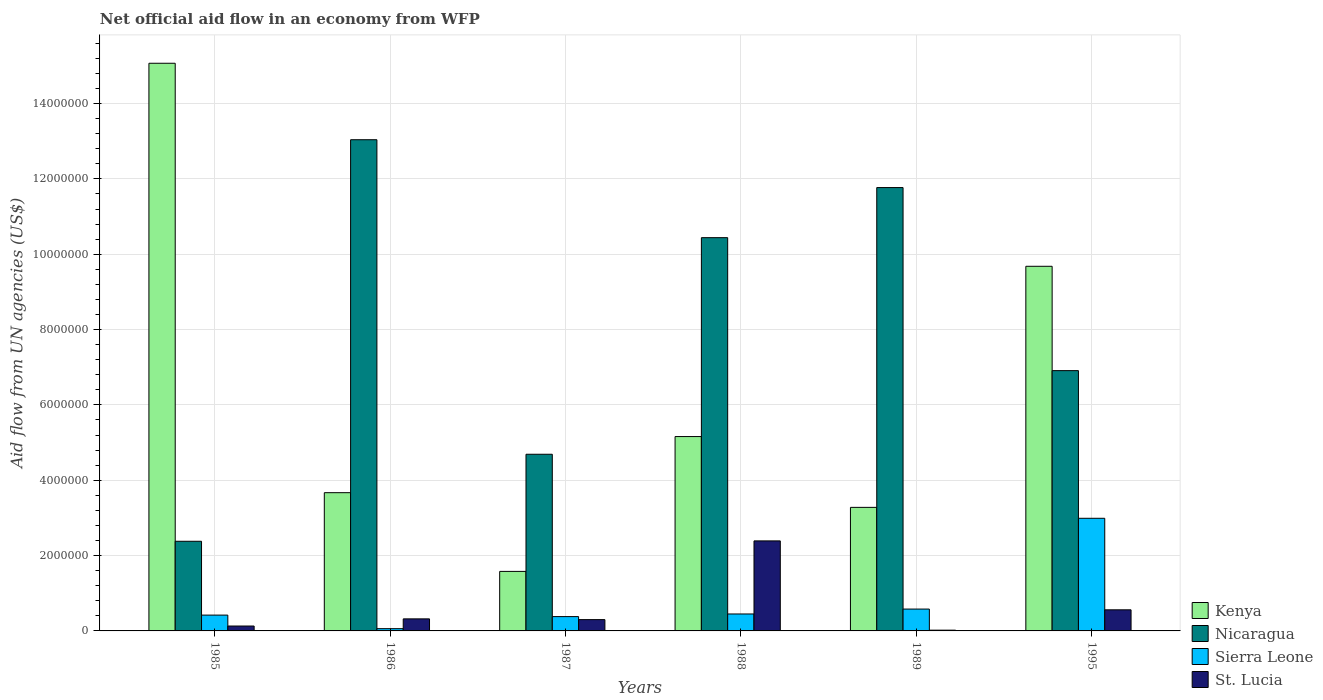How many bars are there on the 3rd tick from the left?
Your answer should be compact. 4. How many bars are there on the 6th tick from the right?
Offer a very short reply. 4. What is the label of the 3rd group of bars from the left?
Give a very brief answer. 1987. Across all years, what is the maximum net official aid flow in Nicaragua?
Offer a terse response. 1.30e+07. Across all years, what is the minimum net official aid flow in Nicaragua?
Provide a short and direct response. 2.38e+06. In which year was the net official aid flow in Nicaragua minimum?
Give a very brief answer. 1985. What is the total net official aid flow in St. Lucia in the graph?
Your answer should be compact. 3.72e+06. What is the difference between the net official aid flow in Nicaragua in 1986 and that in 1988?
Offer a terse response. 2.60e+06. What is the difference between the net official aid flow in St. Lucia in 1988 and the net official aid flow in Sierra Leone in 1987?
Your answer should be compact. 2.01e+06. What is the average net official aid flow in Sierra Leone per year?
Provide a short and direct response. 8.13e+05. In the year 1985, what is the difference between the net official aid flow in St. Lucia and net official aid flow in Kenya?
Your response must be concise. -1.49e+07. What is the ratio of the net official aid flow in Nicaragua in 1985 to that in 1986?
Your answer should be very brief. 0.18. What is the difference between the highest and the second highest net official aid flow in Sierra Leone?
Ensure brevity in your answer.  2.41e+06. What is the difference between the highest and the lowest net official aid flow in Kenya?
Offer a terse response. 1.35e+07. Is the sum of the net official aid flow in Sierra Leone in 1985 and 1995 greater than the maximum net official aid flow in Nicaragua across all years?
Ensure brevity in your answer.  No. What does the 1st bar from the left in 1985 represents?
Offer a terse response. Kenya. What does the 1st bar from the right in 1986 represents?
Your response must be concise. St. Lucia. Is it the case that in every year, the sum of the net official aid flow in Kenya and net official aid flow in Nicaragua is greater than the net official aid flow in Sierra Leone?
Offer a terse response. Yes. How many years are there in the graph?
Keep it short and to the point. 6. Are the values on the major ticks of Y-axis written in scientific E-notation?
Offer a terse response. No. Does the graph contain grids?
Your answer should be compact. Yes. Where does the legend appear in the graph?
Offer a terse response. Bottom right. How are the legend labels stacked?
Offer a very short reply. Vertical. What is the title of the graph?
Keep it short and to the point. Net official aid flow in an economy from WFP. Does "Marshall Islands" appear as one of the legend labels in the graph?
Your response must be concise. No. What is the label or title of the Y-axis?
Provide a succinct answer. Aid flow from UN agencies (US$). What is the Aid flow from UN agencies (US$) in Kenya in 1985?
Offer a very short reply. 1.51e+07. What is the Aid flow from UN agencies (US$) of Nicaragua in 1985?
Provide a short and direct response. 2.38e+06. What is the Aid flow from UN agencies (US$) in Sierra Leone in 1985?
Your answer should be very brief. 4.20e+05. What is the Aid flow from UN agencies (US$) in St. Lucia in 1985?
Offer a terse response. 1.30e+05. What is the Aid flow from UN agencies (US$) of Kenya in 1986?
Your answer should be very brief. 3.67e+06. What is the Aid flow from UN agencies (US$) in Nicaragua in 1986?
Provide a short and direct response. 1.30e+07. What is the Aid flow from UN agencies (US$) in St. Lucia in 1986?
Ensure brevity in your answer.  3.20e+05. What is the Aid flow from UN agencies (US$) of Kenya in 1987?
Give a very brief answer. 1.58e+06. What is the Aid flow from UN agencies (US$) in Nicaragua in 1987?
Keep it short and to the point. 4.69e+06. What is the Aid flow from UN agencies (US$) in St. Lucia in 1987?
Provide a succinct answer. 3.00e+05. What is the Aid flow from UN agencies (US$) in Kenya in 1988?
Your answer should be compact. 5.16e+06. What is the Aid flow from UN agencies (US$) of Nicaragua in 1988?
Ensure brevity in your answer.  1.04e+07. What is the Aid flow from UN agencies (US$) of Sierra Leone in 1988?
Provide a short and direct response. 4.50e+05. What is the Aid flow from UN agencies (US$) in St. Lucia in 1988?
Offer a terse response. 2.39e+06. What is the Aid flow from UN agencies (US$) in Kenya in 1989?
Your answer should be compact. 3.28e+06. What is the Aid flow from UN agencies (US$) of Nicaragua in 1989?
Provide a short and direct response. 1.18e+07. What is the Aid flow from UN agencies (US$) in Sierra Leone in 1989?
Provide a succinct answer. 5.80e+05. What is the Aid flow from UN agencies (US$) in St. Lucia in 1989?
Give a very brief answer. 2.00e+04. What is the Aid flow from UN agencies (US$) in Kenya in 1995?
Make the answer very short. 9.68e+06. What is the Aid flow from UN agencies (US$) in Nicaragua in 1995?
Keep it short and to the point. 6.91e+06. What is the Aid flow from UN agencies (US$) in Sierra Leone in 1995?
Make the answer very short. 2.99e+06. What is the Aid flow from UN agencies (US$) of St. Lucia in 1995?
Keep it short and to the point. 5.60e+05. Across all years, what is the maximum Aid flow from UN agencies (US$) in Kenya?
Your answer should be very brief. 1.51e+07. Across all years, what is the maximum Aid flow from UN agencies (US$) in Nicaragua?
Your answer should be very brief. 1.30e+07. Across all years, what is the maximum Aid flow from UN agencies (US$) in Sierra Leone?
Keep it short and to the point. 2.99e+06. Across all years, what is the maximum Aid flow from UN agencies (US$) in St. Lucia?
Your answer should be very brief. 2.39e+06. Across all years, what is the minimum Aid flow from UN agencies (US$) in Kenya?
Give a very brief answer. 1.58e+06. Across all years, what is the minimum Aid flow from UN agencies (US$) of Nicaragua?
Offer a very short reply. 2.38e+06. Across all years, what is the minimum Aid flow from UN agencies (US$) in Sierra Leone?
Your response must be concise. 6.00e+04. Across all years, what is the minimum Aid flow from UN agencies (US$) of St. Lucia?
Offer a terse response. 2.00e+04. What is the total Aid flow from UN agencies (US$) in Kenya in the graph?
Your answer should be very brief. 3.84e+07. What is the total Aid flow from UN agencies (US$) in Nicaragua in the graph?
Your answer should be very brief. 4.92e+07. What is the total Aid flow from UN agencies (US$) in Sierra Leone in the graph?
Your answer should be compact. 4.88e+06. What is the total Aid flow from UN agencies (US$) of St. Lucia in the graph?
Your answer should be very brief. 3.72e+06. What is the difference between the Aid flow from UN agencies (US$) of Kenya in 1985 and that in 1986?
Ensure brevity in your answer.  1.14e+07. What is the difference between the Aid flow from UN agencies (US$) in Nicaragua in 1985 and that in 1986?
Keep it short and to the point. -1.07e+07. What is the difference between the Aid flow from UN agencies (US$) of Kenya in 1985 and that in 1987?
Provide a short and direct response. 1.35e+07. What is the difference between the Aid flow from UN agencies (US$) in Nicaragua in 1985 and that in 1987?
Your response must be concise. -2.31e+06. What is the difference between the Aid flow from UN agencies (US$) of St. Lucia in 1985 and that in 1987?
Keep it short and to the point. -1.70e+05. What is the difference between the Aid flow from UN agencies (US$) in Kenya in 1985 and that in 1988?
Offer a very short reply. 9.91e+06. What is the difference between the Aid flow from UN agencies (US$) of Nicaragua in 1985 and that in 1988?
Offer a very short reply. -8.06e+06. What is the difference between the Aid flow from UN agencies (US$) in St. Lucia in 1985 and that in 1988?
Offer a terse response. -2.26e+06. What is the difference between the Aid flow from UN agencies (US$) of Kenya in 1985 and that in 1989?
Give a very brief answer. 1.18e+07. What is the difference between the Aid flow from UN agencies (US$) of Nicaragua in 1985 and that in 1989?
Your answer should be very brief. -9.39e+06. What is the difference between the Aid flow from UN agencies (US$) of Sierra Leone in 1985 and that in 1989?
Provide a short and direct response. -1.60e+05. What is the difference between the Aid flow from UN agencies (US$) of Kenya in 1985 and that in 1995?
Your answer should be compact. 5.39e+06. What is the difference between the Aid flow from UN agencies (US$) in Nicaragua in 1985 and that in 1995?
Give a very brief answer. -4.53e+06. What is the difference between the Aid flow from UN agencies (US$) of Sierra Leone in 1985 and that in 1995?
Your answer should be very brief. -2.57e+06. What is the difference between the Aid flow from UN agencies (US$) in St. Lucia in 1985 and that in 1995?
Make the answer very short. -4.30e+05. What is the difference between the Aid flow from UN agencies (US$) of Kenya in 1986 and that in 1987?
Offer a very short reply. 2.09e+06. What is the difference between the Aid flow from UN agencies (US$) of Nicaragua in 1986 and that in 1987?
Your answer should be very brief. 8.35e+06. What is the difference between the Aid flow from UN agencies (US$) of Sierra Leone in 1986 and that in 1987?
Keep it short and to the point. -3.20e+05. What is the difference between the Aid flow from UN agencies (US$) in Kenya in 1986 and that in 1988?
Your response must be concise. -1.49e+06. What is the difference between the Aid flow from UN agencies (US$) of Nicaragua in 1986 and that in 1988?
Your answer should be compact. 2.60e+06. What is the difference between the Aid flow from UN agencies (US$) of Sierra Leone in 1986 and that in 1988?
Ensure brevity in your answer.  -3.90e+05. What is the difference between the Aid flow from UN agencies (US$) of St. Lucia in 1986 and that in 1988?
Make the answer very short. -2.07e+06. What is the difference between the Aid flow from UN agencies (US$) in Nicaragua in 1986 and that in 1989?
Keep it short and to the point. 1.27e+06. What is the difference between the Aid flow from UN agencies (US$) of Sierra Leone in 1986 and that in 1989?
Make the answer very short. -5.20e+05. What is the difference between the Aid flow from UN agencies (US$) in St. Lucia in 1986 and that in 1989?
Ensure brevity in your answer.  3.00e+05. What is the difference between the Aid flow from UN agencies (US$) in Kenya in 1986 and that in 1995?
Provide a short and direct response. -6.01e+06. What is the difference between the Aid flow from UN agencies (US$) of Nicaragua in 1986 and that in 1995?
Offer a very short reply. 6.13e+06. What is the difference between the Aid flow from UN agencies (US$) of Sierra Leone in 1986 and that in 1995?
Ensure brevity in your answer.  -2.93e+06. What is the difference between the Aid flow from UN agencies (US$) of Kenya in 1987 and that in 1988?
Make the answer very short. -3.58e+06. What is the difference between the Aid flow from UN agencies (US$) of Nicaragua in 1987 and that in 1988?
Your response must be concise. -5.75e+06. What is the difference between the Aid flow from UN agencies (US$) in Sierra Leone in 1987 and that in 1988?
Offer a terse response. -7.00e+04. What is the difference between the Aid flow from UN agencies (US$) in St. Lucia in 1987 and that in 1988?
Ensure brevity in your answer.  -2.09e+06. What is the difference between the Aid flow from UN agencies (US$) in Kenya in 1987 and that in 1989?
Your response must be concise. -1.70e+06. What is the difference between the Aid flow from UN agencies (US$) of Nicaragua in 1987 and that in 1989?
Make the answer very short. -7.08e+06. What is the difference between the Aid flow from UN agencies (US$) of Sierra Leone in 1987 and that in 1989?
Offer a very short reply. -2.00e+05. What is the difference between the Aid flow from UN agencies (US$) of Kenya in 1987 and that in 1995?
Make the answer very short. -8.10e+06. What is the difference between the Aid flow from UN agencies (US$) of Nicaragua in 1987 and that in 1995?
Keep it short and to the point. -2.22e+06. What is the difference between the Aid flow from UN agencies (US$) of Sierra Leone in 1987 and that in 1995?
Keep it short and to the point. -2.61e+06. What is the difference between the Aid flow from UN agencies (US$) in Kenya in 1988 and that in 1989?
Your response must be concise. 1.88e+06. What is the difference between the Aid flow from UN agencies (US$) of Nicaragua in 1988 and that in 1989?
Give a very brief answer. -1.33e+06. What is the difference between the Aid flow from UN agencies (US$) in Sierra Leone in 1988 and that in 1989?
Provide a succinct answer. -1.30e+05. What is the difference between the Aid flow from UN agencies (US$) in St. Lucia in 1988 and that in 1989?
Offer a terse response. 2.37e+06. What is the difference between the Aid flow from UN agencies (US$) in Kenya in 1988 and that in 1995?
Your answer should be very brief. -4.52e+06. What is the difference between the Aid flow from UN agencies (US$) of Nicaragua in 1988 and that in 1995?
Keep it short and to the point. 3.53e+06. What is the difference between the Aid flow from UN agencies (US$) in Sierra Leone in 1988 and that in 1995?
Provide a short and direct response. -2.54e+06. What is the difference between the Aid flow from UN agencies (US$) in St. Lucia in 1988 and that in 1995?
Provide a short and direct response. 1.83e+06. What is the difference between the Aid flow from UN agencies (US$) in Kenya in 1989 and that in 1995?
Your response must be concise. -6.40e+06. What is the difference between the Aid flow from UN agencies (US$) in Nicaragua in 1989 and that in 1995?
Provide a short and direct response. 4.86e+06. What is the difference between the Aid flow from UN agencies (US$) in Sierra Leone in 1989 and that in 1995?
Provide a short and direct response. -2.41e+06. What is the difference between the Aid flow from UN agencies (US$) in St. Lucia in 1989 and that in 1995?
Make the answer very short. -5.40e+05. What is the difference between the Aid flow from UN agencies (US$) of Kenya in 1985 and the Aid flow from UN agencies (US$) of Nicaragua in 1986?
Provide a succinct answer. 2.03e+06. What is the difference between the Aid flow from UN agencies (US$) of Kenya in 1985 and the Aid flow from UN agencies (US$) of Sierra Leone in 1986?
Make the answer very short. 1.50e+07. What is the difference between the Aid flow from UN agencies (US$) in Kenya in 1985 and the Aid flow from UN agencies (US$) in St. Lucia in 1986?
Offer a very short reply. 1.48e+07. What is the difference between the Aid flow from UN agencies (US$) in Nicaragua in 1985 and the Aid flow from UN agencies (US$) in Sierra Leone in 1986?
Ensure brevity in your answer.  2.32e+06. What is the difference between the Aid flow from UN agencies (US$) in Nicaragua in 1985 and the Aid flow from UN agencies (US$) in St. Lucia in 1986?
Offer a very short reply. 2.06e+06. What is the difference between the Aid flow from UN agencies (US$) of Sierra Leone in 1985 and the Aid flow from UN agencies (US$) of St. Lucia in 1986?
Offer a very short reply. 1.00e+05. What is the difference between the Aid flow from UN agencies (US$) in Kenya in 1985 and the Aid flow from UN agencies (US$) in Nicaragua in 1987?
Provide a succinct answer. 1.04e+07. What is the difference between the Aid flow from UN agencies (US$) of Kenya in 1985 and the Aid flow from UN agencies (US$) of Sierra Leone in 1987?
Make the answer very short. 1.47e+07. What is the difference between the Aid flow from UN agencies (US$) in Kenya in 1985 and the Aid flow from UN agencies (US$) in St. Lucia in 1987?
Your response must be concise. 1.48e+07. What is the difference between the Aid flow from UN agencies (US$) in Nicaragua in 1985 and the Aid flow from UN agencies (US$) in St. Lucia in 1987?
Provide a short and direct response. 2.08e+06. What is the difference between the Aid flow from UN agencies (US$) of Sierra Leone in 1985 and the Aid flow from UN agencies (US$) of St. Lucia in 1987?
Your answer should be very brief. 1.20e+05. What is the difference between the Aid flow from UN agencies (US$) of Kenya in 1985 and the Aid flow from UN agencies (US$) of Nicaragua in 1988?
Keep it short and to the point. 4.63e+06. What is the difference between the Aid flow from UN agencies (US$) of Kenya in 1985 and the Aid flow from UN agencies (US$) of Sierra Leone in 1988?
Offer a terse response. 1.46e+07. What is the difference between the Aid flow from UN agencies (US$) of Kenya in 1985 and the Aid flow from UN agencies (US$) of St. Lucia in 1988?
Make the answer very short. 1.27e+07. What is the difference between the Aid flow from UN agencies (US$) of Nicaragua in 1985 and the Aid flow from UN agencies (US$) of Sierra Leone in 1988?
Your response must be concise. 1.93e+06. What is the difference between the Aid flow from UN agencies (US$) of Sierra Leone in 1985 and the Aid flow from UN agencies (US$) of St. Lucia in 1988?
Keep it short and to the point. -1.97e+06. What is the difference between the Aid flow from UN agencies (US$) in Kenya in 1985 and the Aid flow from UN agencies (US$) in Nicaragua in 1989?
Your response must be concise. 3.30e+06. What is the difference between the Aid flow from UN agencies (US$) of Kenya in 1985 and the Aid flow from UN agencies (US$) of Sierra Leone in 1989?
Offer a terse response. 1.45e+07. What is the difference between the Aid flow from UN agencies (US$) in Kenya in 1985 and the Aid flow from UN agencies (US$) in St. Lucia in 1989?
Your answer should be very brief. 1.50e+07. What is the difference between the Aid flow from UN agencies (US$) in Nicaragua in 1985 and the Aid flow from UN agencies (US$) in Sierra Leone in 1989?
Give a very brief answer. 1.80e+06. What is the difference between the Aid flow from UN agencies (US$) in Nicaragua in 1985 and the Aid flow from UN agencies (US$) in St. Lucia in 1989?
Offer a terse response. 2.36e+06. What is the difference between the Aid flow from UN agencies (US$) in Sierra Leone in 1985 and the Aid flow from UN agencies (US$) in St. Lucia in 1989?
Provide a succinct answer. 4.00e+05. What is the difference between the Aid flow from UN agencies (US$) in Kenya in 1985 and the Aid flow from UN agencies (US$) in Nicaragua in 1995?
Make the answer very short. 8.16e+06. What is the difference between the Aid flow from UN agencies (US$) of Kenya in 1985 and the Aid flow from UN agencies (US$) of Sierra Leone in 1995?
Ensure brevity in your answer.  1.21e+07. What is the difference between the Aid flow from UN agencies (US$) of Kenya in 1985 and the Aid flow from UN agencies (US$) of St. Lucia in 1995?
Your answer should be compact. 1.45e+07. What is the difference between the Aid flow from UN agencies (US$) in Nicaragua in 1985 and the Aid flow from UN agencies (US$) in Sierra Leone in 1995?
Make the answer very short. -6.10e+05. What is the difference between the Aid flow from UN agencies (US$) of Nicaragua in 1985 and the Aid flow from UN agencies (US$) of St. Lucia in 1995?
Ensure brevity in your answer.  1.82e+06. What is the difference between the Aid flow from UN agencies (US$) of Sierra Leone in 1985 and the Aid flow from UN agencies (US$) of St. Lucia in 1995?
Give a very brief answer. -1.40e+05. What is the difference between the Aid flow from UN agencies (US$) of Kenya in 1986 and the Aid flow from UN agencies (US$) of Nicaragua in 1987?
Offer a terse response. -1.02e+06. What is the difference between the Aid flow from UN agencies (US$) in Kenya in 1986 and the Aid flow from UN agencies (US$) in Sierra Leone in 1987?
Make the answer very short. 3.29e+06. What is the difference between the Aid flow from UN agencies (US$) in Kenya in 1986 and the Aid flow from UN agencies (US$) in St. Lucia in 1987?
Provide a succinct answer. 3.37e+06. What is the difference between the Aid flow from UN agencies (US$) of Nicaragua in 1986 and the Aid flow from UN agencies (US$) of Sierra Leone in 1987?
Offer a very short reply. 1.27e+07. What is the difference between the Aid flow from UN agencies (US$) of Nicaragua in 1986 and the Aid flow from UN agencies (US$) of St. Lucia in 1987?
Offer a terse response. 1.27e+07. What is the difference between the Aid flow from UN agencies (US$) of Kenya in 1986 and the Aid flow from UN agencies (US$) of Nicaragua in 1988?
Offer a very short reply. -6.77e+06. What is the difference between the Aid flow from UN agencies (US$) of Kenya in 1986 and the Aid flow from UN agencies (US$) of Sierra Leone in 1988?
Give a very brief answer. 3.22e+06. What is the difference between the Aid flow from UN agencies (US$) of Kenya in 1986 and the Aid flow from UN agencies (US$) of St. Lucia in 1988?
Your answer should be very brief. 1.28e+06. What is the difference between the Aid flow from UN agencies (US$) in Nicaragua in 1986 and the Aid flow from UN agencies (US$) in Sierra Leone in 1988?
Keep it short and to the point. 1.26e+07. What is the difference between the Aid flow from UN agencies (US$) in Nicaragua in 1986 and the Aid flow from UN agencies (US$) in St. Lucia in 1988?
Your answer should be compact. 1.06e+07. What is the difference between the Aid flow from UN agencies (US$) of Sierra Leone in 1986 and the Aid flow from UN agencies (US$) of St. Lucia in 1988?
Provide a short and direct response. -2.33e+06. What is the difference between the Aid flow from UN agencies (US$) of Kenya in 1986 and the Aid flow from UN agencies (US$) of Nicaragua in 1989?
Your answer should be very brief. -8.10e+06. What is the difference between the Aid flow from UN agencies (US$) in Kenya in 1986 and the Aid flow from UN agencies (US$) in Sierra Leone in 1989?
Your answer should be compact. 3.09e+06. What is the difference between the Aid flow from UN agencies (US$) in Kenya in 1986 and the Aid flow from UN agencies (US$) in St. Lucia in 1989?
Offer a very short reply. 3.65e+06. What is the difference between the Aid flow from UN agencies (US$) of Nicaragua in 1986 and the Aid flow from UN agencies (US$) of Sierra Leone in 1989?
Give a very brief answer. 1.25e+07. What is the difference between the Aid flow from UN agencies (US$) of Nicaragua in 1986 and the Aid flow from UN agencies (US$) of St. Lucia in 1989?
Your response must be concise. 1.30e+07. What is the difference between the Aid flow from UN agencies (US$) in Sierra Leone in 1986 and the Aid flow from UN agencies (US$) in St. Lucia in 1989?
Offer a very short reply. 4.00e+04. What is the difference between the Aid flow from UN agencies (US$) in Kenya in 1986 and the Aid flow from UN agencies (US$) in Nicaragua in 1995?
Keep it short and to the point. -3.24e+06. What is the difference between the Aid flow from UN agencies (US$) in Kenya in 1986 and the Aid flow from UN agencies (US$) in Sierra Leone in 1995?
Keep it short and to the point. 6.80e+05. What is the difference between the Aid flow from UN agencies (US$) of Kenya in 1986 and the Aid flow from UN agencies (US$) of St. Lucia in 1995?
Your answer should be compact. 3.11e+06. What is the difference between the Aid flow from UN agencies (US$) of Nicaragua in 1986 and the Aid flow from UN agencies (US$) of Sierra Leone in 1995?
Your answer should be compact. 1.00e+07. What is the difference between the Aid flow from UN agencies (US$) of Nicaragua in 1986 and the Aid flow from UN agencies (US$) of St. Lucia in 1995?
Your answer should be compact. 1.25e+07. What is the difference between the Aid flow from UN agencies (US$) of Sierra Leone in 1986 and the Aid flow from UN agencies (US$) of St. Lucia in 1995?
Keep it short and to the point. -5.00e+05. What is the difference between the Aid flow from UN agencies (US$) in Kenya in 1987 and the Aid flow from UN agencies (US$) in Nicaragua in 1988?
Keep it short and to the point. -8.86e+06. What is the difference between the Aid flow from UN agencies (US$) of Kenya in 1987 and the Aid flow from UN agencies (US$) of Sierra Leone in 1988?
Offer a very short reply. 1.13e+06. What is the difference between the Aid flow from UN agencies (US$) in Kenya in 1987 and the Aid flow from UN agencies (US$) in St. Lucia in 1988?
Your answer should be very brief. -8.10e+05. What is the difference between the Aid flow from UN agencies (US$) in Nicaragua in 1987 and the Aid flow from UN agencies (US$) in Sierra Leone in 1988?
Give a very brief answer. 4.24e+06. What is the difference between the Aid flow from UN agencies (US$) of Nicaragua in 1987 and the Aid flow from UN agencies (US$) of St. Lucia in 1988?
Offer a terse response. 2.30e+06. What is the difference between the Aid flow from UN agencies (US$) of Sierra Leone in 1987 and the Aid flow from UN agencies (US$) of St. Lucia in 1988?
Ensure brevity in your answer.  -2.01e+06. What is the difference between the Aid flow from UN agencies (US$) of Kenya in 1987 and the Aid flow from UN agencies (US$) of Nicaragua in 1989?
Your response must be concise. -1.02e+07. What is the difference between the Aid flow from UN agencies (US$) in Kenya in 1987 and the Aid flow from UN agencies (US$) in Sierra Leone in 1989?
Offer a terse response. 1.00e+06. What is the difference between the Aid flow from UN agencies (US$) of Kenya in 1987 and the Aid flow from UN agencies (US$) of St. Lucia in 1989?
Make the answer very short. 1.56e+06. What is the difference between the Aid flow from UN agencies (US$) of Nicaragua in 1987 and the Aid flow from UN agencies (US$) of Sierra Leone in 1989?
Provide a short and direct response. 4.11e+06. What is the difference between the Aid flow from UN agencies (US$) in Nicaragua in 1987 and the Aid flow from UN agencies (US$) in St. Lucia in 1989?
Your answer should be very brief. 4.67e+06. What is the difference between the Aid flow from UN agencies (US$) of Sierra Leone in 1987 and the Aid flow from UN agencies (US$) of St. Lucia in 1989?
Ensure brevity in your answer.  3.60e+05. What is the difference between the Aid flow from UN agencies (US$) of Kenya in 1987 and the Aid flow from UN agencies (US$) of Nicaragua in 1995?
Offer a terse response. -5.33e+06. What is the difference between the Aid flow from UN agencies (US$) of Kenya in 1987 and the Aid flow from UN agencies (US$) of Sierra Leone in 1995?
Ensure brevity in your answer.  -1.41e+06. What is the difference between the Aid flow from UN agencies (US$) in Kenya in 1987 and the Aid flow from UN agencies (US$) in St. Lucia in 1995?
Offer a very short reply. 1.02e+06. What is the difference between the Aid flow from UN agencies (US$) in Nicaragua in 1987 and the Aid flow from UN agencies (US$) in Sierra Leone in 1995?
Offer a terse response. 1.70e+06. What is the difference between the Aid flow from UN agencies (US$) in Nicaragua in 1987 and the Aid flow from UN agencies (US$) in St. Lucia in 1995?
Your response must be concise. 4.13e+06. What is the difference between the Aid flow from UN agencies (US$) in Sierra Leone in 1987 and the Aid flow from UN agencies (US$) in St. Lucia in 1995?
Ensure brevity in your answer.  -1.80e+05. What is the difference between the Aid flow from UN agencies (US$) in Kenya in 1988 and the Aid flow from UN agencies (US$) in Nicaragua in 1989?
Your response must be concise. -6.61e+06. What is the difference between the Aid flow from UN agencies (US$) of Kenya in 1988 and the Aid flow from UN agencies (US$) of Sierra Leone in 1989?
Offer a terse response. 4.58e+06. What is the difference between the Aid flow from UN agencies (US$) of Kenya in 1988 and the Aid flow from UN agencies (US$) of St. Lucia in 1989?
Your answer should be very brief. 5.14e+06. What is the difference between the Aid flow from UN agencies (US$) in Nicaragua in 1988 and the Aid flow from UN agencies (US$) in Sierra Leone in 1989?
Your answer should be very brief. 9.86e+06. What is the difference between the Aid flow from UN agencies (US$) in Nicaragua in 1988 and the Aid flow from UN agencies (US$) in St. Lucia in 1989?
Keep it short and to the point. 1.04e+07. What is the difference between the Aid flow from UN agencies (US$) of Kenya in 1988 and the Aid flow from UN agencies (US$) of Nicaragua in 1995?
Offer a very short reply. -1.75e+06. What is the difference between the Aid flow from UN agencies (US$) of Kenya in 1988 and the Aid flow from UN agencies (US$) of Sierra Leone in 1995?
Offer a terse response. 2.17e+06. What is the difference between the Aid flow from UN agencies (US$) in Kenya in 1988 and the Aid flow from UN agencies (US$) in St. Lucia in 1995?
Your answer should be compact. 4.60e+06. What is the difference between the Aid flow from UN agencies (US$) of Nicaragua in 1988 and the Aid flow from UN agencies (US$) of Sierra Leone in 1995?
Provide a succinct answer. 7.45e+06. What is the difference between the Aid flow from UN agencies (US$) of Nicaragua in 1988 and the Aid flow from UN agencies (US$) of St. Lucia in 1995?
Provide a short and direct response. 9.88e+06. What is the difference between the Aid flow from UN agencies (US$) in Kenya in 1989 and the Aid flow from UN agencies (US$) in Nicaragua in 1995?
Keep it short and to the point. -3.63e+06. What is the difference between the Aid flow from UN agencies (US$) of Kenya in 1989 and the Aid flow from UN agencies (US$) of Sierra Leone in 1995?
Your answer should be very brief. 2.90e+05. What is the difference between the Aid flow from UN agencies (US$) in Kenya in 1989 and the Aid flow from UN agencies (US$) in St. Lucia in 1995?
Offer a terse response. 2.72e+06. What is the difference between the Aid flow from UN agencies (US$) in Nicaragua in 1989 and the Aid flow from UN agencies (US$) in Sierra Leone in 1995?
Provide a succinct answer. 8.78e+06. What is the difference between the Aid flow from UN agencies (US$) in Nicaragua in 1989 and the Aid flow from UN agencies (US$) in St. Lucia in 1995?
Make the answer very short. 1.12e+07. What is the difference between the Aid flow from UN agencies (US$) in Sierra Leone in 1989 and the Aid flow from UN agencies (US$) in St. Lucia in 1995?
Make the answer very short. 2.00e+04. What is the average Aid flow from UN agencies (US$) in Kenya per year?
Offer a very short reply. 6.41e+06. What is the average Aid flow from UN agencies (US$) of Nicaragua per year?
Provide a succinct answer. 8.20e+06. What is the average Aid flow from UN agencies (US$) in Sierra Leone per year?
Ensure brevity in your answer.  8.13e+05. What is the average Aid flow from UN agencies (US$) in St. Lucia per year?
Your answer should be compact. 6.20e+05. In the year 1985, what is the difference between the Aid flow from UN agencies (US$) in Kenya and Aid flow from UN agencies (US$) in Nicaragua?
Provide a succinct answer. 1.27e+07. In the year 1985, what is the difference between the Aid flow from UN agencies (US$) of Kenya and Aid flow from UN agencies (US$) of Sierra Leone?
Your answer should be very brief. 1.46e+07. In the year 1985, what is the difference between the Aid flow from UN agencies (US$) in Kenya and Aid flow from UN agencies (US$) in St. Lucia?
Offer a terse response. 1.49e+07. In the year 1985, what is the difference between the Aid flow from UN agencies (US$) in Nicaragua and Aid flow from UN agencies (US$) in Sierra Leone?
Give a very brief answer. 1.96e+06. In the year 1985, what is the difference between the Aid flow from UN agencies (US$) of Nicaragua and Aid flow from UN agencies (US$) of St. Lucia?
Offer a terse response. 2.25e+06. In the year 1985, what is the difference between the Aid flow from UN agencies (US$) of Sierra Leone and Aid flow from UN agencies (US$) of St. Lucia?
Your answer should be very brief. 2.90e+05. In the year 1986, what is the difference between the Aid flow from UN agencies (US$) in Kenya and Aid flow from UN agencies (US$) in Nicaragua?
Your response must be concise. -9.37e+06. In the year 1986, what is the difference between the Aid flow from UN agencies (US$) in Kenya and Aid flow from UN agencies (US$) in Sierra Leone?
Your response must be concise. 3.61e+06. In the year 1986, what is the difference between the Aid flow from UN agencies (US$) of Kenya and Aid flow from UN agencies (US$) of St. Lucia?
Keep it short and to the point. 3.35e+06. In the year 1986, what is the difference between the Aid flow from UN agencies (US$) in Nicaragua and Aid flow from UN agencies (US$) in Sierra Leone?
Ensure brevity in your answer.  1.30e+07. In the year 1986, what is the difference between the Aid flow from UN agencies (US$) of Nicaragua and Aid flow from UN agencies (US$) of St. Lucia?
Offer a very short reply. 1.27e+07. In the year 1986, what is the difference between the Aid flow from UN agencies (US$) in Sierra Leone and Aid flow from UN agencies (US$) in St. Lucia?
Your answer should be very brief. -2.60e+05. In the year 1987, what is the difference between the Aid flow from UN agencies (US$) in Kenya and Aid flow from UN agencies (US$) in Nicaragua?
Provide a short and direct response. -3.11e+06. In the year 1987, what is the difference between the Aid flow from UN agencies (US$) in Kenya and Aid flow from UN agencies (US$) in Sierra Leone?
Provide a succinct answer. 1.20e+06. In the year 1987, what is the difference between the Aid flow from UN agencies (US$) in Kenya and Aid flow from UN agencies (US$) in St. Lucia?
Your answer should be compact. 1.28e+06. In the year 1987, what is the difference between the Aid flow from UN agencies (US$) of Nicaragua and Aid flow from UN agencies (US$) of Sierra Leone?
Ensure brevity in your answer.  4.31e+06. In the year 1987, what is the difference between the Aid flow from UN agencies (US$) in Nicaragua and Aid flow from UN agencies (US$) in St. Lucia?
Your answer should be compact. 4.39e+06. In the year 1988, what is the difference between the Aid flow from UN agencies (US$) of Kenya and Aid flow from UN agencies (US$) of Nicaragua?
Provide a short and direct response. -5.28e+06. In the year 1988, what is the difference between the Aid flow from UN agencies (US$) in Kenya and Aid flow from UN agencies (US$) in Sierra Leone?
Make the answer very short. 4.71e+06. In the year 1988, what is the difference between the Aid flow from UN agencies (US$) in Kenya and Aid flow from UN agencies (US$) in St. Lucia?
Ensure brevity in your answer.  2.77e+06. In the year 1988, what is the difference between the Aid flow from UN agencies (US$) of Nicaragua and Aid flow from UN agencies (US$) of Sierra Leone?
Your answer should be very brief. 9.99e+06. In the year 1988, what is the difference between the Aid flow from UN agencies (US$) of Nicaragua and Aid flow from UN agencies (US$) of St. Lucia?
Give a very brief answer. 8.05e+06. In the year 1988, what is the difference between the Aid flow from UN agencies (US$) in Sierra Leone and Aid flow from UN agencies (US$) in St. Lucia?
Your response must be concise. -1.94e+06. In the year 1989, what is the difference between the Aid flow from UN agencies (US$) in Kenya and Aid flow from UN agencies (US$) in Nicaragua?
Provide a short and direct response. -8.49e+06. In the year 1989, what is the difference between the Aid flow from UN agencies (US$) in Kenya and Aid flow from UN agencies (US$) in Sierra Leone?
Offer a terse response. 2.70e+06. In the year 1989, what is the difference between the Aid flow from UN agencies (US$) of Kenya and Aid flow from UN agencies (US$) of St. Lucia?
Provide a short and direct response. 3.26e+06. In the year 1989, what is the difference between the Aid flow from UN agencies (US$) in Nicaragua and Aid flow from UN agencies (US$) in Sierra Leone?
Your response must be concise. 1.12e+07. In the year 1989, what is the difference between the Aid flow from UN agencies (US$) in Nicaragua and Aid flow from UN agencies (US$) in St. Lucia?
Your answer should be very brief. 1.18e+07. In the year 1989, what is the difference between the Aid flow from UN agencies (US$) of Sierra Leone and Aid flow from UN agencies (US$) of St. Lucia?
Provide a succinct answer. 5.60e+05. In the year 1995, what is the difference between the Aid flow from UN agencies (US$) of Kenya and Aid flow from UN agencies (US$) of Nicaragua?
Your response must be concise. 2.77e+06. In the year 1995, what is the difference between the Aid flow from UN agencies (US$) in Kenya and Aid flow from UN agencies (US$) in Sierra Leone?
Provide a succinct answer. 6.69e+06. In the year 1995, what is the difference between the Aid flow from UN agencies (US$) of Kenya and Aid flow from UN agencies (US$) of St. Lucia?
Give a very brief answer. 9.12e+06. In the year 1995, what is the difference between the Aid flow from UN agencies (US$) in Nicaragua and Aid flow from UN agencies (US$) in Sierra Leone?
Offer a very short reply. 3.92e+06. In the year 1995, what is the difference between the Aid flow from UN agencies (US$) of Nicaragua and Aid flow from UN agencies (US$) of St. Lucia?
Offer a very short reply. 6.35e+06. In the year 1995, what is the difference between the Aid flow from UN agencies (US$) of Sierra Leone and Aid flow from UN agencies (US$) of St. Lucia?
Give a very brief answer. 2.43e+06. What is the ratio of the Aid flow from UN agencies (US$) in Kenya in 1985 to that in 1986?
Provide a short and direct response. 4.11. What is the ratio of the Aid flow from UN agencies (US$) of Nicaragua in 1985 to that in 1986?
Your response must be concise. 0.18. What is the ratio of the Aid flow from UN agencies (US$) of Sierra Leone in 1985 to that in 1986?
Provide a succinct answer. 7. What is the ratio of the Aid flow from UN agencies (US$) of St. Lucia in 1985 to that in 1986?
Your answer should be very brief. 0.41. What is the ratio of the Aid flow from UN agencies (US$) in Kenya in 1985 to that in 1987?
Provide a succinct answer. 9.54. What is the ratio of the Aid flow from UN agencies (US$) in Nicaragua in 1985 to that in 1987?
Provide a succinct answer. 0.51. What is the ratio of the Aid flow from UN agencies (US$) of Sierra Leone in 1985 to that in 1987?
Provide a short and direct response. 1.11. What is the ratio of the Aid flow from UN agencies (US$) in St. Lucia in 1985 to that in 1987?
Give a very brief answer. 0.43. What is the ratio of the Aid flow from UN agencies (US$) of Kenya in 1985 to that in 1988?
Offer a terse response. 2.92. What is the ratio of the Aid flow from UN agencies (US$) of Nicaragua in 1985 to that in 1988?
Ensure brevity in your answer.  0.23. What is the ratio of the Aid flow from UN agencies (US$) in St. Lucia in 1985 to that in 1988?
Offer a terse response. 0.05. What is the ratio of the Aid flow from UN agencies (US$) in Kenya in 1985 to that in 1989?
Make the answer very short. 4.59. What is the ratio of the Aid flow from UN agencies (US$) in Nicaragua in 1985 to that in 1989?
Offer a very short reply. 0.2. What is the ratio of the Aid flow from UN agencies (US$) in Sierra Leone in 1985 to that in 1989?
Provide a short and direct response. 0.72. What is the ratio of the Aid flow from UN agencies (US$) of Kenya in 1985 to that in 1995?
Keep it short and to the point. 1.56. What is the ratio of the Aid flow from UN agencies (US$) of Nicaragua in 1985 to that in 1995?
Keep it short and to the point. 0.34. What is the ratio of the Aid flow from UN agencies (US$) in Sierra Leone in 1985 to that in 1995?
Provide a succinct answer. 0.14. What is the ratio of the Aid flow from UN agencies (US$) in St. Lucia in 1985 to that in 1995?
Offer a terse response. 0.23. What is the ratio of the Aid flow from UN agencies (US$) of Kenya in 1986 to that in 1987?
Your answer should be compact. 2.32. What is the ratio of the Aid flow from UN agencies (US$) of Nicaragua in 1986 to that in 1987?
Give a very brief answer. 2.78. What is the ratio of the Aid flow from UN agencies (US$) in Sierra Leone in 1986 to that in 1987?
Offer a very short reply. 0.16. What is the ratio of the Aid flow from UN agencies (US$) in St. Lucia in 1986 to that in 1987?
Make the answer very short. 1.07. What is the ratio of the Aid flow from UN agencies (US$) in Kenya in 1986 to that in 1988?
Offer a very short reply. 0.71. What is the ratio of the Aid flow from UN agencies (US$) of Nicaragua in 1986 to that in 1988?
Offer a very short reply. 1.25. What is the ratio of the Aid flow from UN agencies (US$) in Sierra Leone in 1986 to that in 1988?
Ensure brevity in your answer.  0.13. What is the ratio of the Aid flow from UN agencies (US$) of St. Lucia in 1986 to that in 1988?
Make the answer very short. 0.13. What is the ratio of the Aid flow from UN agencies (US$) in Kenya in 1986 to that in 1989?
Your answer should be very brief. 1.12. What is the ratio of the Aid flow from UN agencies (US$) of Nicaragua in 1986 to that in 1989?
Your answer should be compact. 1.11. What is the ratio of the Aid flow from UN agencies (US$) of Sierra Leone in 1986 to that in 1989?
Ensure brevity in your answer.  0.1. What is the ratio of the Aid flow from UN agencies (US$) in Kenya in 1986 to that in 1995?
Make the answer very short. 0.38. What is the ratio of the Aid flow from UN agencies (US$) in Nicaragua in 1986 to that in 1995?
Your response must be concise. 1.89. What is the ratio of the Aid flow from UN agencies (US$) in Sierra Leone in 1986 to that in 1995?
Ensure brevity in your answer.  0.02. What is the ratio of the Aid flow from UN agencies (US$) in Kenya in 1987 to that in 1988?
Your answer should be compact. 0.31. What is the ratio of the Aid flow from UN agencies (US$) in Nicaragua in 1987 to that in 1988?
Your response must be concise. 0.45. What is the ratio of the Aid flow from UN agencies (US$) in Sierra Leone in 1987 to that in 1988?
Make the answer very short. 0.84. What is the ratio of the Aid flow from UN agencies (US$) in St. Lucia in 1987 to that in 1988?
Offer a terse response. 0.13. What is the ratio of the Aid flow from UN agencies (US$) of Kenya in 1987 to that in 1989?
Provide a succinct answer. 0.48. What is the ratio of the Aid flow from UN agencies (US$) in Nicaragua in 1987 to that in 1989?
Ensure brevity in your answer.  0.4. What is the ratio of the Aid flow from UN agencies (US$) of Sierra Leone in 1987 to that in 1989?
Offer a very short reply. 0.66. What is the ratio of the Aid flow from UN agencies (US$) in Kenya in 1987 to that in 1995?
Your response must be concise. 0.16. What is the ratio of the Aid flow from UN agencies (US$) of Nicaragua in 1987 to that in 1995?
Give a very brief answer. 0.68. What is the ratio of the Aid flow from UN agencies (US$) of Sierra Leone in 1987 to that in 1995?
Make the answer very short. 0.13. What is the ratio of the Aid flow from UN agencies (US$) in St. Lucia in 1987 to that in 1995?
Provide a succinct answer. 0.54. What is the ratio of the Aid flow from UN agencies (US$) of Kenya in 1988 to that in 1989?
Offer a very short reply. 1.57. What is the ratio of the Aid flow from UN agencies (US$) of Nicaragua in 1988 to that in 1989?
Offer a very short reply. 0.89. What is the ratio of the Aid flow from UN agencies (US$) in Sierra Leone in 1988 to that in 1989?
Make the answer very short. 0.78. What is the ratio of the Aid flow from UN agencies (US$) of St. Lucia in 1988 to that in 1989?
Provide a short and direct response. 119.5. What is the ratio of the Aid flow from UN agencies (US$) in Kenya in 1988 to that in 1995?
Your response must be concise. 0.53. What is the ratio of the Aid flow from UN agencies (US$) of Nicaragua in 1988 to that in 1995?
Ensure brevity in your answer.  1.51. What is the ratio of the Aid flow from UN agencies (US$) in Sierra Leone in 1988 to that in 1995?
Offer a terse response. 0.15. What is the ratio of the Aid flow from UN agencies (US$) in St. Lucia in 1988 to that in 1995?
Your answer should be very brief. 4.27. What is the ratio of the Aid flow from UN agencies (US$) of Kenya in 1989 to that in 1995?
Offer a terse response. 0.34. What is the ratio of the Aid flow from UN agencies (US$) of Nicaragua in 1989 to that in 1995?
Make the answer very short. 1.7. What is the ratio of the Aid flow from UN agencies (US$) in Sierra Leone in 1989 to that in 1995?
Make the answer very short. 0.19. What is the ratio of the Aid flow from UN agencies (US$) in St. Lucia in 1989 to that in 1995?
Your response must be concise. 0.04. What is the difference between the highest and the second highest Aid flow from UN agencies (US$) in Kenya?
Offer a very short reply. 5.39e+06. What is the difference between the highest and the second highest Aid flow from UN agencies (US$) in Nicaragua?
Your answer should be compact. 1.27e+06. What is the difference between the highest and the second highest Aid flow from UN agencies (US$) of Sierra Leone?
Your response must be concise. 2.41e+06. What is the difference between the highest and the second highest Aid flow from UN agencies (US$) in St. Lucia?
Ensure brevity in your answer.  1.83e+06. What is the difference between the highest and the lowest Aid flow from UN agencies (US$) of Kenya?
Your answer should be very brief. 1.35e+07. What is the difference between the highest and the lowest Aid flow from UN agencies (US$) in Nicaragua?
Make the answer very short. 1.07e+07. What is the difference between the highest and the lowest Aid flow from UN agencies (US$) of Sierra Leone?
Provide a short and direct response. 2.93e+06. What is the difference between the highest and the lowest Aid flow from UN agencies (US$) of St. Lucia?
Offer a very short reply. 2.37e+06. 